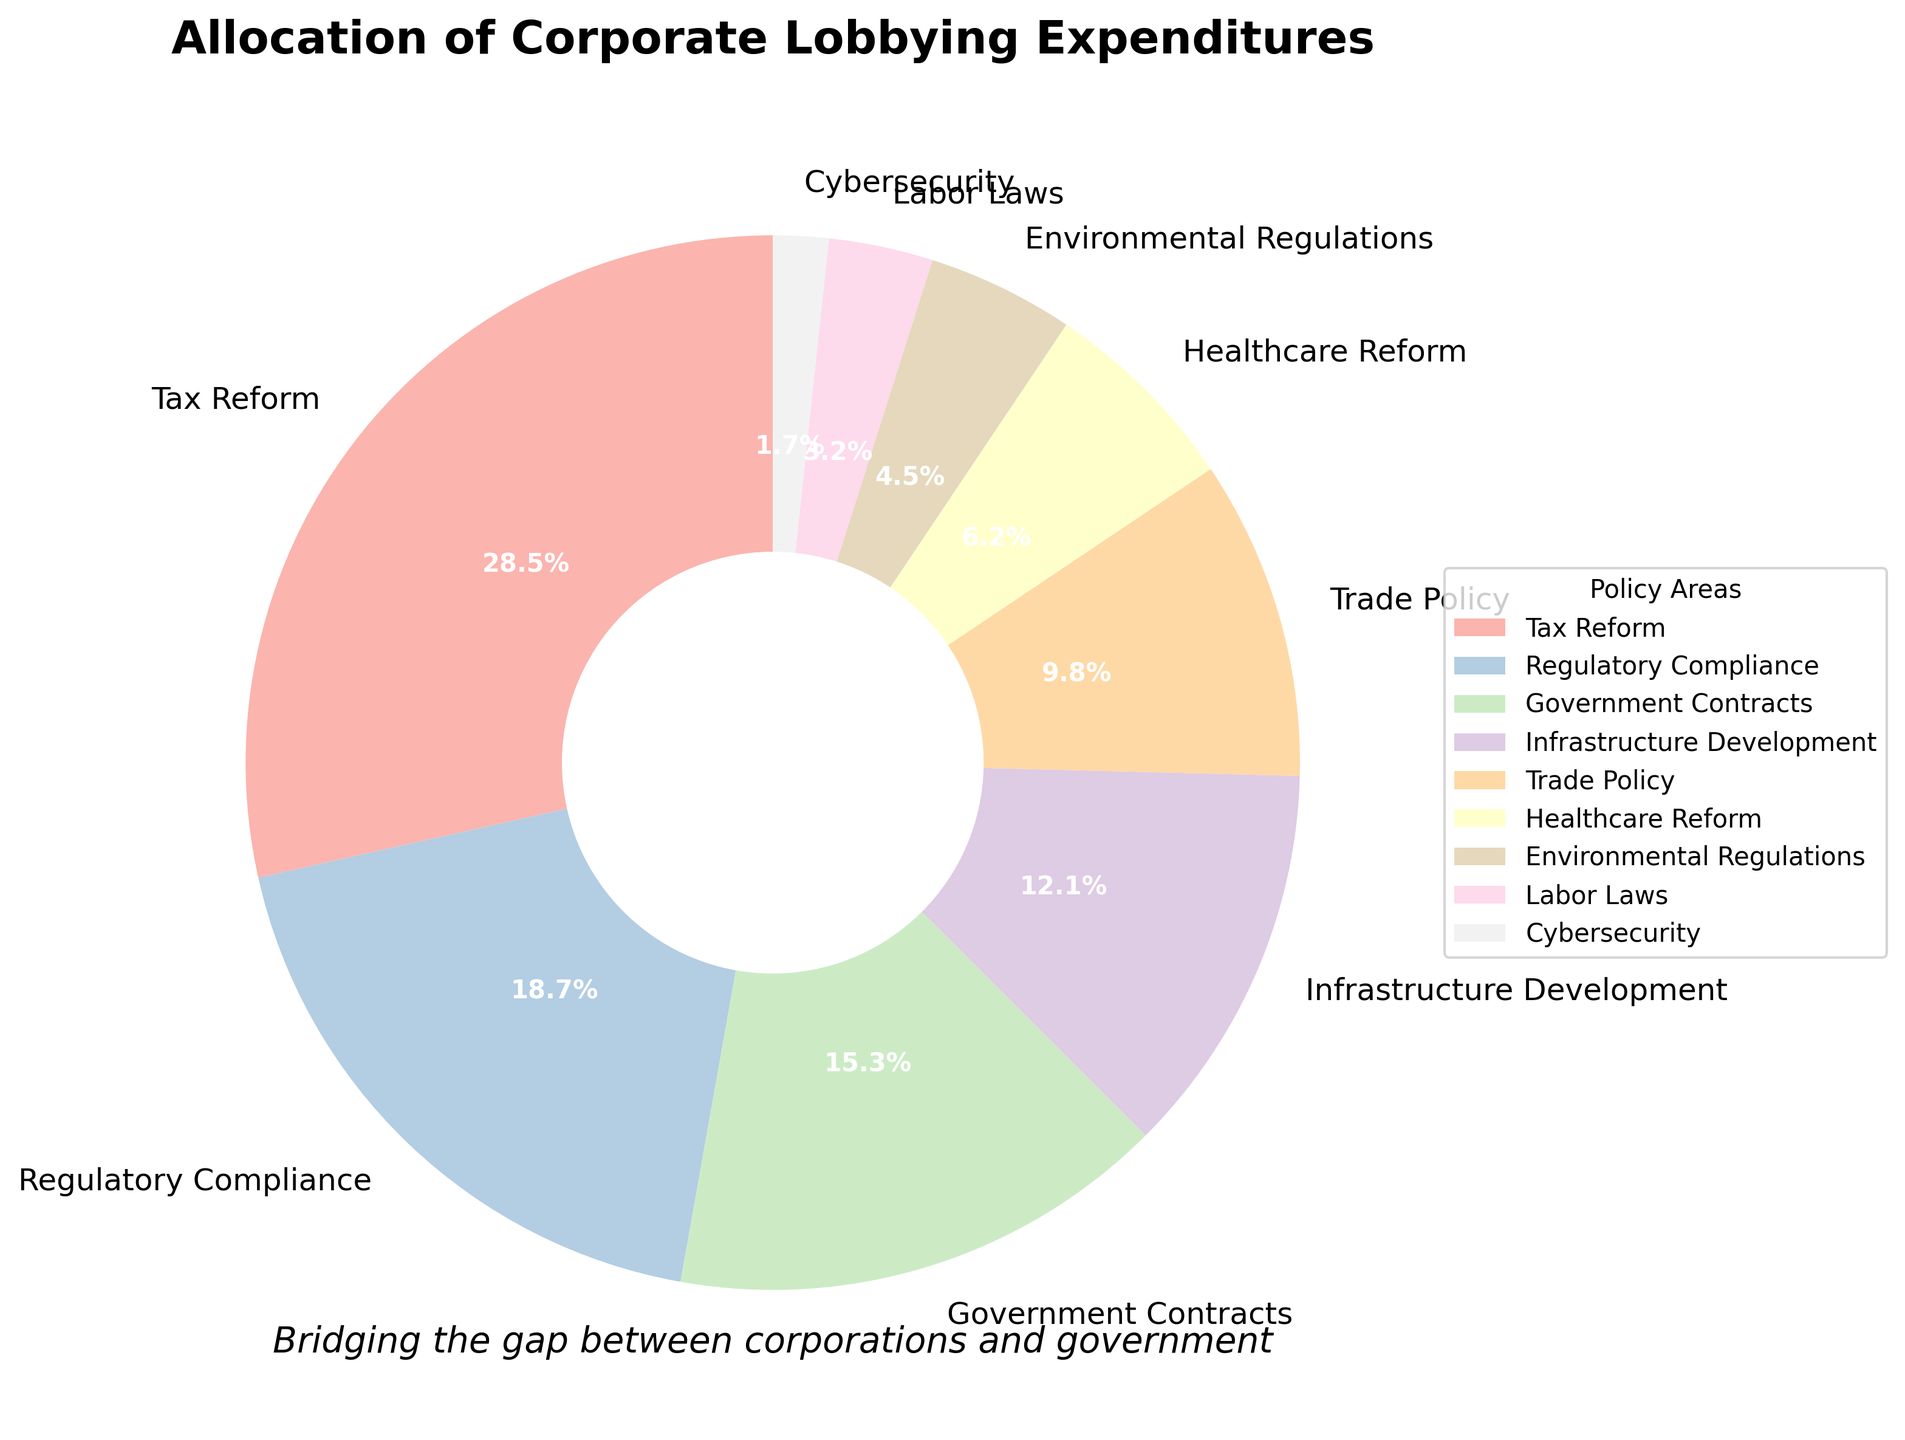Which policy area receives the highest allocation of corporate lobbying expenditures? The policy area with the highest expenditure percentage is displayed as the largest wedge in the pie chart, which is labeled accordingly.
Answer: Tax Reform Which two policy areas together make up less than 10% of the total corporate lobbying expenditures? By examining each segment, the smallest wedges are identified and their expenditure percentages are added together. The two smallest wedges are Cybersecurity (1.7%) and Labor Laws (3.2%), summing to 4.9%, which is less than 10%.
Answer: Cybersecurity and Labor Laws How much more is spent on Tax Reform compared to Healthcare Reform? To find the difference, subtract the expenditure percentage of Healthcare Reform from that of Tax Reform: 28.5% - 6.2% = 22.3%.
Answer: 22.3% What is the combined expenditure percentage for the top three policy areas? The expenditure percentages of the top three policy areas are added together: Tax Reform (28.5%), Regulatory Compliance (18.7%), and Government Contracts (15.3%). The combined total is 28.5% + 18.7% + 15.3% = 62.5%.
Answer: 62.5% Which policy area allocates just over 10% of the total corporate lobbying expenditures? The pie chart segment—with a value slightly above 10%—is identified as Infrastructure Development, which is labeled with an expenditure percentage of 12.1%.
Answer: Infrastructure Development Is the expenditure on Environmental Regulations more or less than half of that on Trade Policy? Half of Trade Policy's expenditure is calculated as 9.8% / 2 = 4.9%. Comparing with Environmental Regulations (4.5%), it is seen that 4.5% < 4.9%.
Answer: Less What is the total expenditure percentage allocated to policy areas related to economic issues (Tax Reform, Trade Policy, and Regulatory Compliance)? The expenditure percentages for these economic policy areas are added together: Tax Reform (28.5%), Trade Policy (9.8%), and Regulatory Compliance (18.7%). The combined total is 28.5% + 9.8% + 18.7% = 57.0%.
Answer: 57.0% Are there more policy areas with expenditures above or below 10%? Count the number of policy areas with expenditures above 10% and those below 10%. Above 10%: Tax Reform, Regulatory Compliance, Government Contracts, and Infrastructure Development (4 areas). Below 10%: Trade Policy, Healthcare Reform, Environmental Regulations, Labor Laws, and Cybersecurity (5 areas).
Answer: Below What percentage of the total lobbying expenditure is allocated to non-economic policy areas (Government Contracts, Infrastructure Development, Healthcare Reform, Environmental Regulations, Labor Laws, and Cybersecurity) collectively? Adding the percentages of these non-economic policy areas: Government Contracts (15.3%), Infrastructure Development (12.1%), Healthcare Reform (6.2%), Environmental Regulations (4.5%), Labor Laws (3.2%), and Cybersecurity (1.7%). The total is 15.3% + 12.1% + 6.2% + 4.5% + 3.2% + 1.7% = 43.0%.
Answer: 43.0% What is the smallest percentage allocation found in the pie chart, and which policy area does it correspond to? The smallest wedge in the chart represents Cybersecurity, which is labeled with an expenditure percentage of 1.7%.
Answer: 1.7%, Cybersecurity 